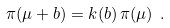<formula> <loc_0><loc_0><loc_500><loc_500>\pi ( \mu + b ) = k ( b ) \, \pi ( \mu ) \ .</formula> 